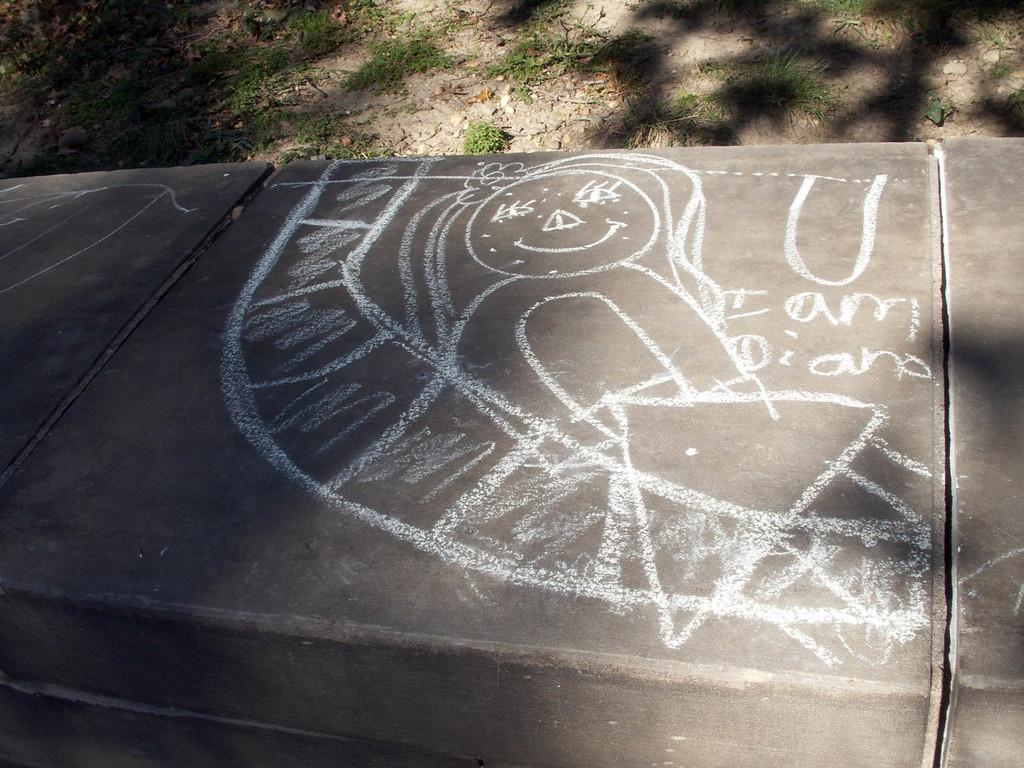What is on the floor in the image? There is a sketch on the floor in the image. What type of vegetation is visible at the top of the image? There is grass visible at the top of the image. Where is the grass located? The grass is on the land. What flavor of key is depicted in the sketch on the floor? There is no key present in the image, and therefore no flavor can be determined. 